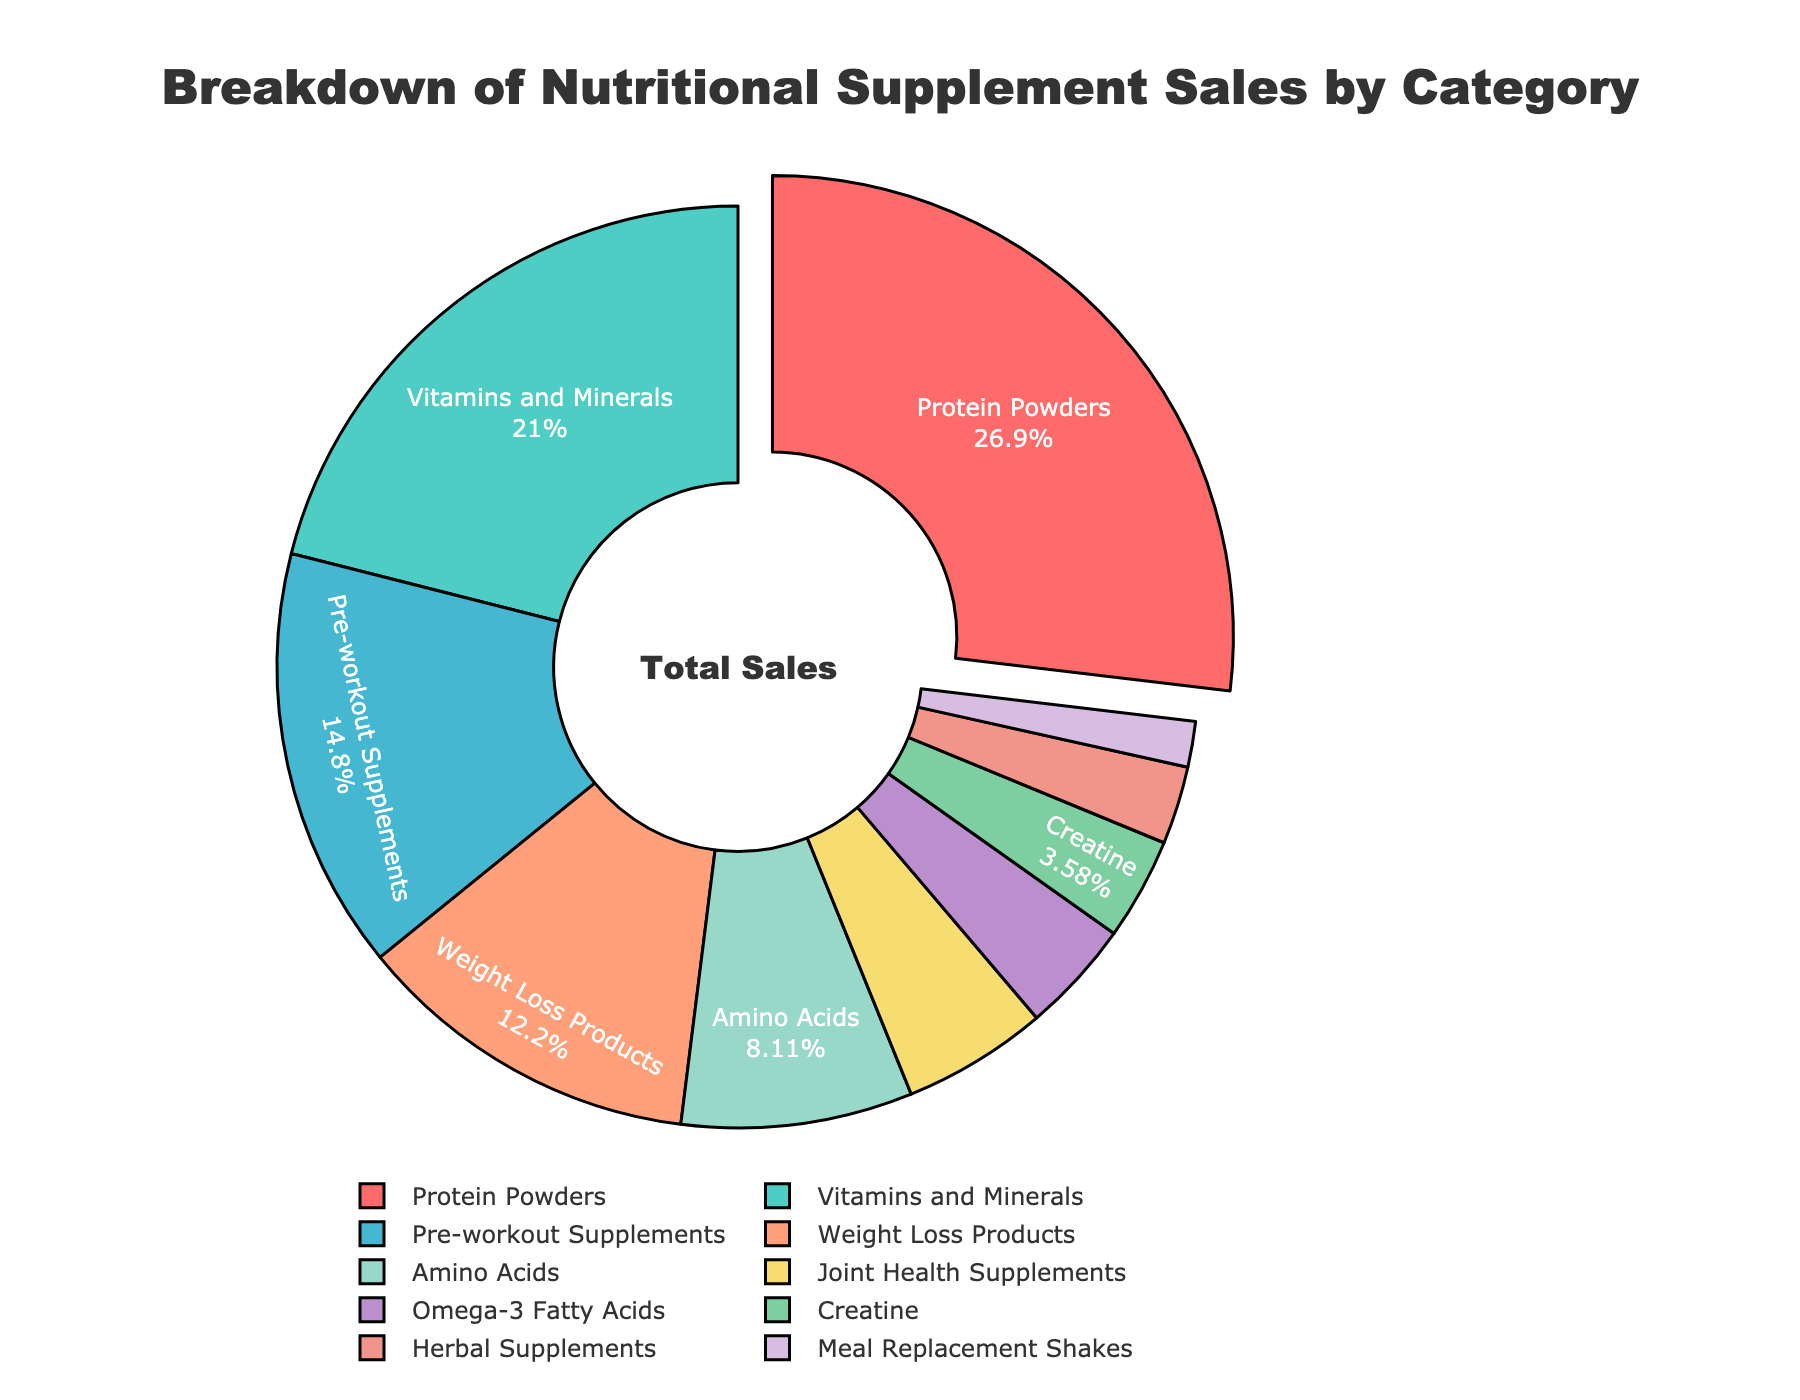Which category of nutritional supplements accounts for the highest percentage of sales? Look at the category with the largest segment in the pie chart. The chart highlights the largest segment by pulling it out slightly. The "Protein Powders" category is the largest segment.
Answer: Protein Powders How much greater is the percentage of sales for Protein Powders compared to Creatine? Identify the segments for Protein Powders and Creatine on the pie chart. Subtract the sales percentage of Creatine (3.8%) from that of Protein Powders (28.5%). 28.5% - 3.8% = 24.7%.
Answer: 24.7% What are the combined sales percentages of Vitamins and Minerals and Pre-workout Supplements? Identify the sales percentages for Vitamins and Minerals (22.3%) and Pre-workout Supplements (15.7%). Sum these percentages: 22.3% + 15.7% = 38%.
Answer: 38% Which category has a lower sales percentage: Joint Health Supplements or Amino Acids? Compare the segments for Joint Health Supplements (5.4%) and Amino Acids (8.6%). The Joint Health Supplements segment is smaller, thus having a lower percentage.
Answer: Joint Health Supplements What is the total percentage of sales for categories with sales percentages less than 5%? Identify the categories with percentages less than 5%: Joint Health Supplements (5.4%), Omega-3 Fatty Acids (4.2%), Creatine (3.8%), Herbal Supplements (2.9%), and Meal Replacement Shakes (1.7%). Sum these values: 4.2% + 3.8% + 2.9% + 1.7% = 12.6%.
Answer: 12.6% Is the sales percentage for Weight Loss Products higher or lower than for Amino Acids? Compare the segments of Weight Loss Products (12.9%) and Amino Acids (8.6%). The Weight Loss Products segment is larger, so its percentage is higher.
Answer: Higher Which category has the smallest sales percentage, and what is it? Look for the smallest segment in the pie chart. The "Meal Replacement Shakes" segment is the smallest with a sales percentage of 1.7%.
Answer: Meal Replacement Shakes, 1.7% What is the sales percentage for the category represented by the green segment in the pie chart? Identify the green segment in the pie chart, which is "Vitamins and Minerals." Its sales percentage is 22.3%.
Answer: 22.3% If you combine the sales percentages of Herbal Supplements and Meal Replacement Shakes, what portion of the total sales do they account for? Sum the percentages for Herbal Supplements (2.9%) and Meal Replacement Shakes (1.7%): 2.9% + 1.7% = 4.6%.
Answer: 4.6% How do the combined sales percentages of Protein Powders and Pre-workout Supplements compare to the combined sales percentages of Vitamins and Minerals and Weight Loss Products? Calculate the combined percentage for Protein Powders (28.5%) and Pre-workout Supplements (15.7%): 28.5% + 15.7% = 44.2%. Calculate the combined percentage for Vitamins and Minerals (22.3%) and Weight Loss Products (12.9%): 22.3% + 12.9% = 35.2%. Compare 44.2% and 35.2%.
Answer: 44.2% is greater than 35.2% 